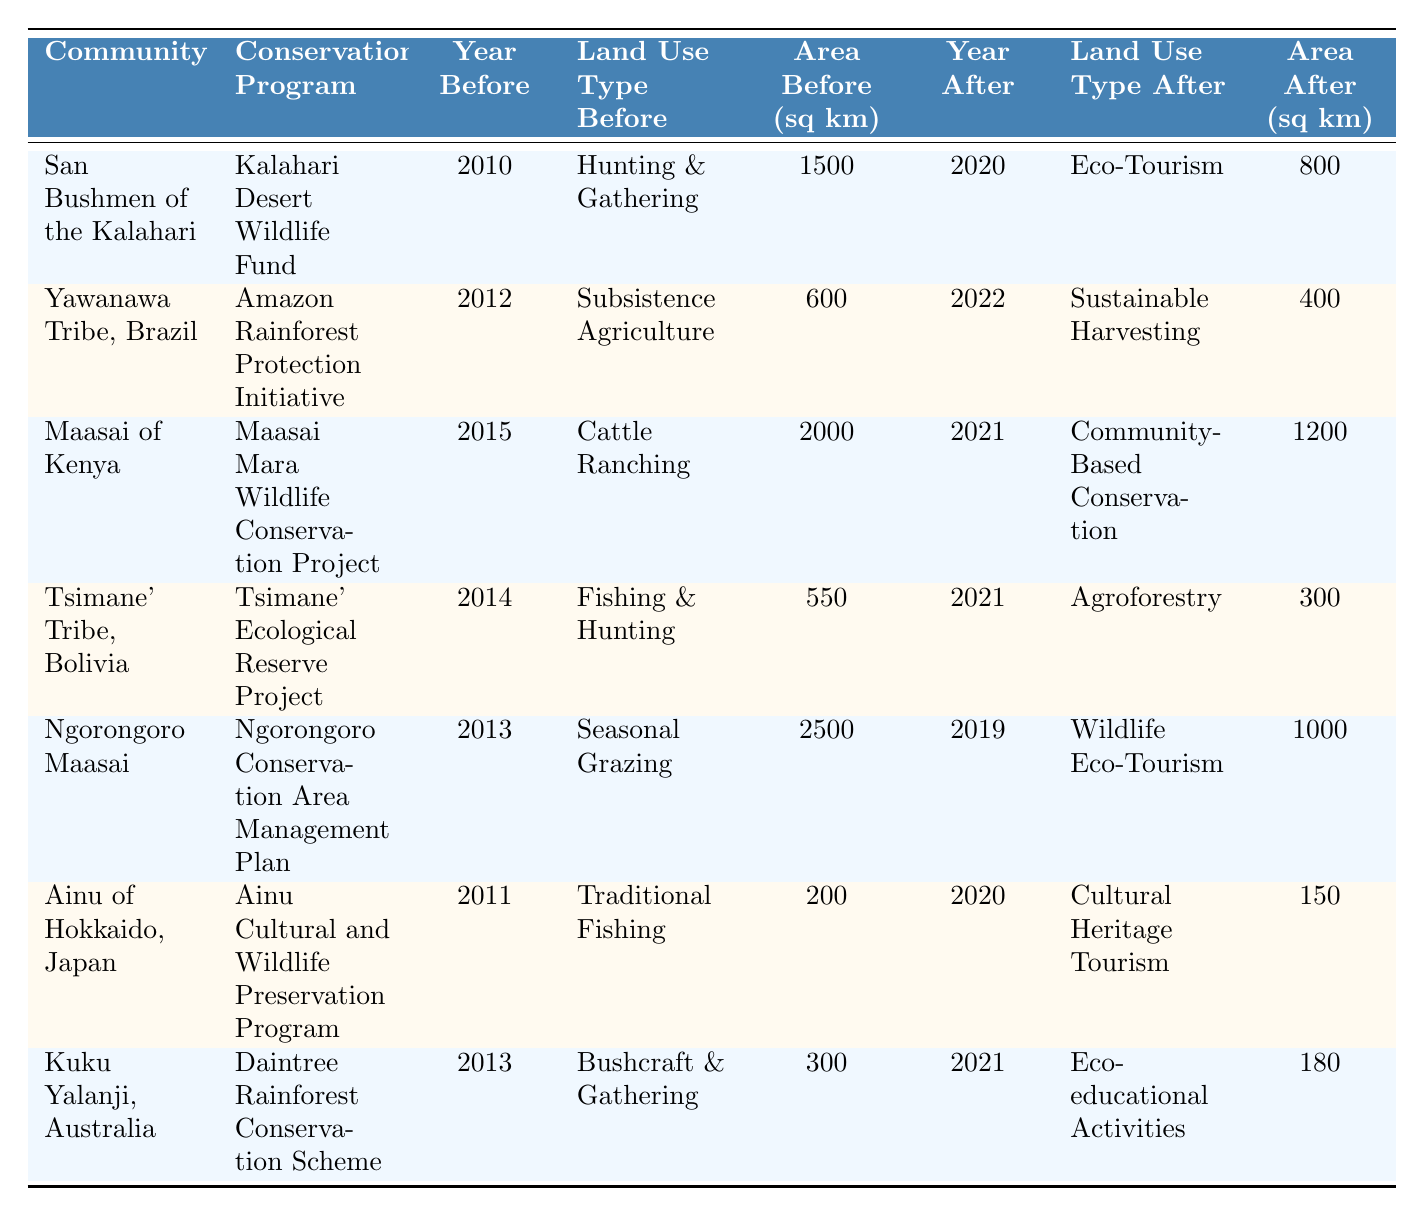What was the land use type change for the San Bushmen of the Kalahari? The table shows that the San Bushmen shifted from Hunting & Gathering to Eco-Tourism from 2010 to 2020.
Answer: Eco-Tourism What was the area used for sustainable harvesting by the Yawanawa Tribe after conservation? According to the table, the Yawanawa Tribe used 400 sq km for Sustainable Harvesting after the conservation efforts.
Answer: 400 sq km Did the Maasai of Kenya increase or decrease their area used after conservation? The area used decreased from 2000 sq km (Cattle Ranching) to 1200 sq km (Community-Based Conservation), indicating a decrease.
Answer: Decrease What is the total area used before and after for the Ngorongoro Maasai? The total area before conservation is 2500 sq km, and after is 1000 sq km. Adding these gives 2500 + 1000 = 3500 sq km.
Answer: 3500 sq km Is it true that the Ainu of Hokkaido reduced their area used following conservation efforts? Yes, they reduced their area from 200 sq km (Traditional Fishing) to 150 sq km (Cultural Heritage Tourism), indicating a reduction.
Answer: Yes What was the average area change across the table, and was it positive or negative? The area before conservation sums to 6000 sq km, and the area after sums to 3090 sq km. The average change is (6000 - 3090) / 7 = 414.29 sq km decrease per community.
Answer: Negative How many communities transitioned to eco-tourism related land use? From the table, both the San Bushmen and Ngorongoro Maasai transitioned to eco-tourism (Eco-Tourism and Wildlife Eco-Tourism), totaling two communities.
Answer: 2 Communities What is the difference in area used for fishing and hunting before and after for the Tsimane' Tribe? The area used for Fishing & Hunting before was 550 sq km and after for Agroforestry was 300 sq km. The difference is 550 - 300 = 250 sq km decrease.
Answer: 250 sq km decrease 